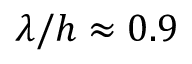Convert formula to latex. <formula><loc_0><loc_0><loc_500><loc_500>\lambda / h \approx 0 . 9</formula> 